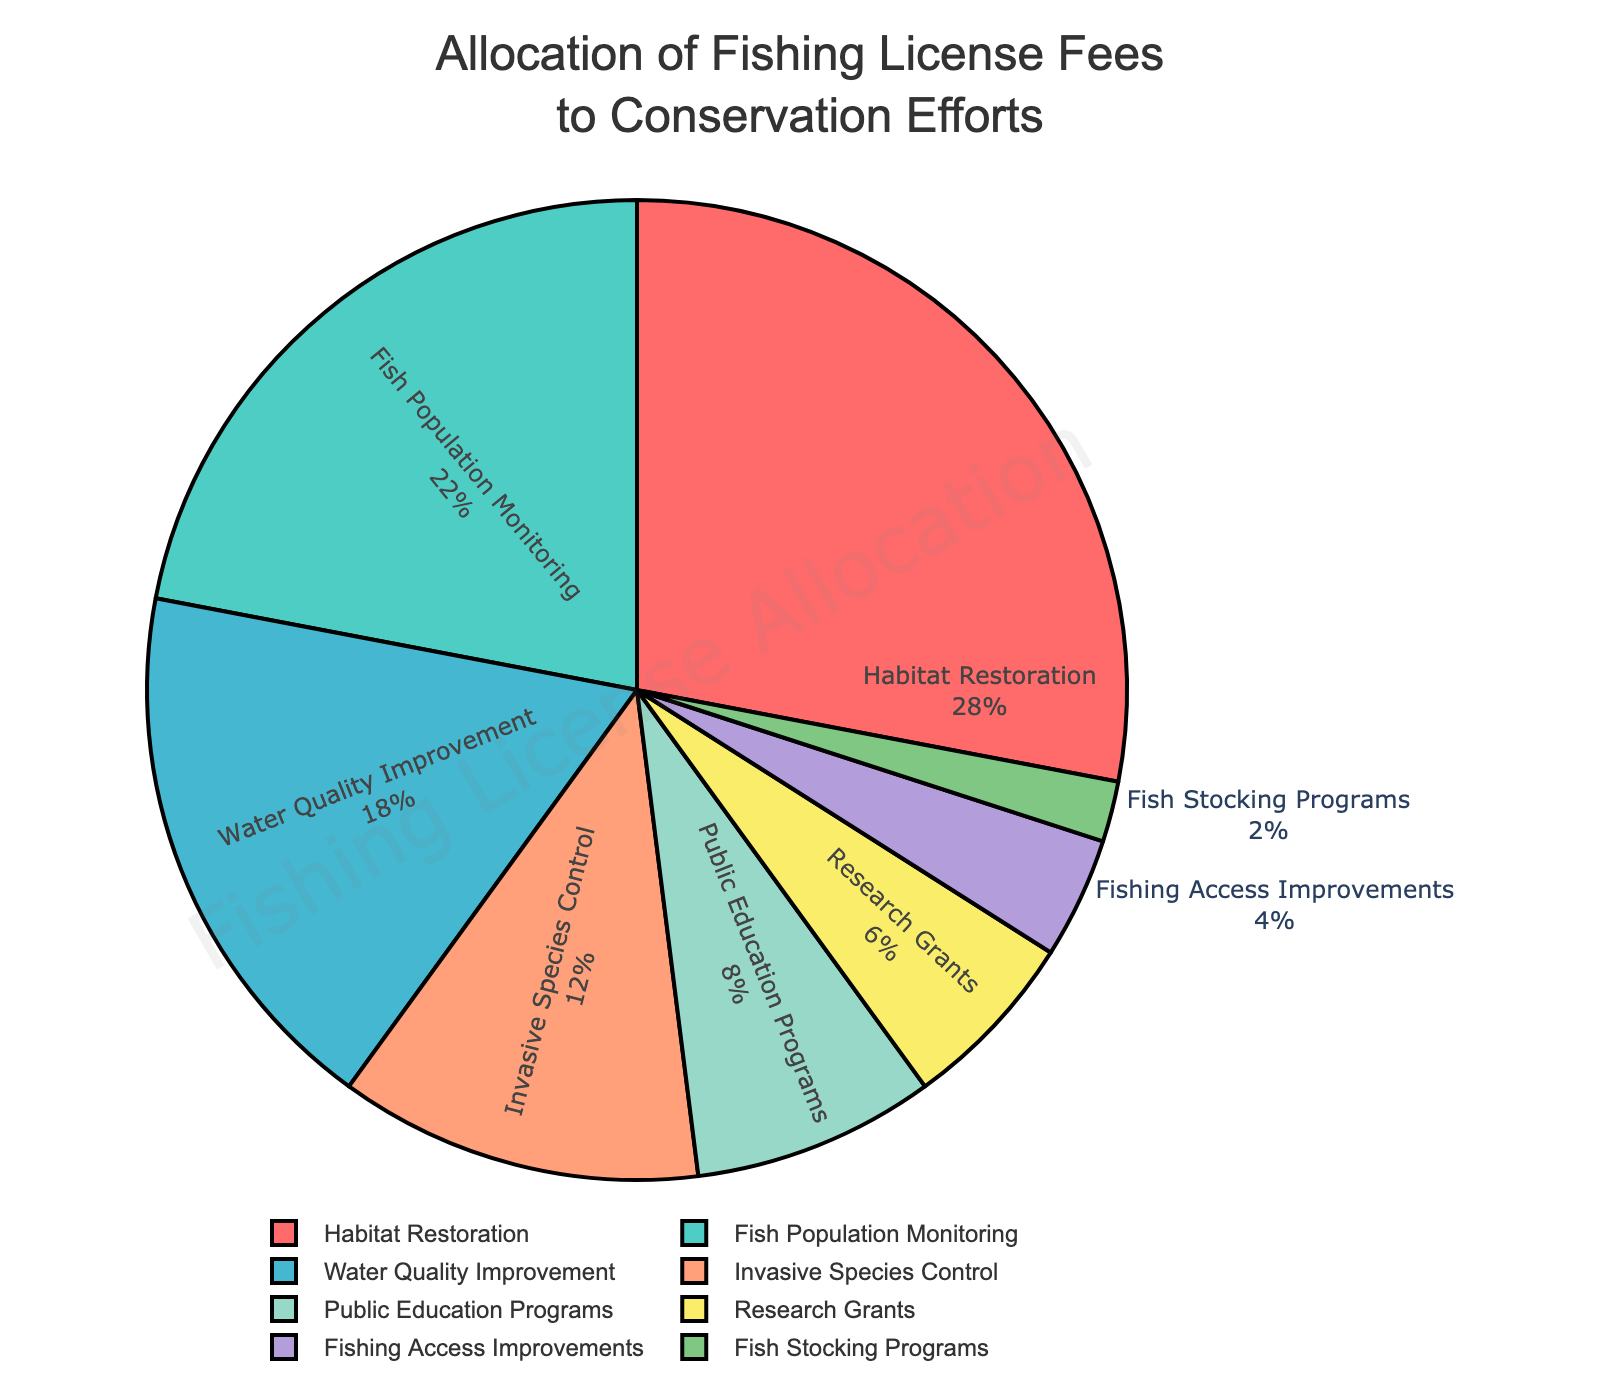What percentage of the fees is allocated to Habitat Restoration? Look at the "Habitat Restoration" portion of the pie chart and read the percentage value.
Answer: 28% What is the combined percentage allocated to Public Education Programs and Fish Stocking Programs? Add the percentages of "Public Education Programs" (8%) and "Fish Stocking Programs" (2%) by looking at their respective sections in the pie chart. 8% + 2% = 10%
Answer: 10% Which category receives more funding: Water Quality Improvement or Fish Population Monitoring? Compare the percentage values for "Water Quality Improvement" (18%) and "Fish Population Monitoring" (22%). Since 22% > 18%, "Fish Population Monitoring" receives more funding.
Answer: Fish Population Monitoring What is the total percentage allocated to categories that receive less than 10% of the funds each? Identify categories with less than 10%: "Public Education Programs" (8%), "Research Grants" (6%), "Fishing Access Improvements" (4%), and "Fish Stocking Programs" (2%). Add their percentages: 8% + 6% + 4% + 2% = 20%
Answer: 20% What's the difference in funding between Invasive Species Control and Fishing Access Improvements? Subtract the percentage for "Fishing Access Improvements" (4%) from "Invasive Species Control" (12%). 12% - 4% = 8%
Answer: 8% Which category has the smallest allocation? Look for the category with the smallest percentage value in the pie chart. "Fish Stocking Programs" is 2%, which is the smallest.
Answer: Fish Stocking Programs How does the percentage allocated to Habitat Restoration compare to that of Water Quality Improvement and Invasive Species Control combined? Add the percentages for "Water Quality Improvement" (18%) and "Invasive Species Control" (12%), then compare to "Habitat Restoration" (28%). 18% + 12% = 30%, which is more than 28%.
Answer: Less What is the average percentage allocation for the categories: Fish Population Monitoring, Water Quality Improvement, and Invasive Species Control? Calculate the average by summing the percentages for "Fish Population Monitoring" (22%), "Water Quality Improvement" (18%), and "Invasive Species Control" (12%), then divide by 3. (22% + 18% + 12%) / 3 = 17.33%
Answer: 17.33% What's the total percentage allocated to the top three funded categories? Identify the top three categories by percentage: "Habitat Restoration" (28%), "Fish Population Monitoring" (22%), "Water Quality Improvement" (18%). Add their percentages: 28% + 22% + 18% = 68%
Answer: 68% What is the percentage difference between Public Education Programs and Research Grants? Subtract the percentage of "Research Grants" (6%) from "Public Education Programs" (8%). 8% - 6% = 2%
Answer: 2% 